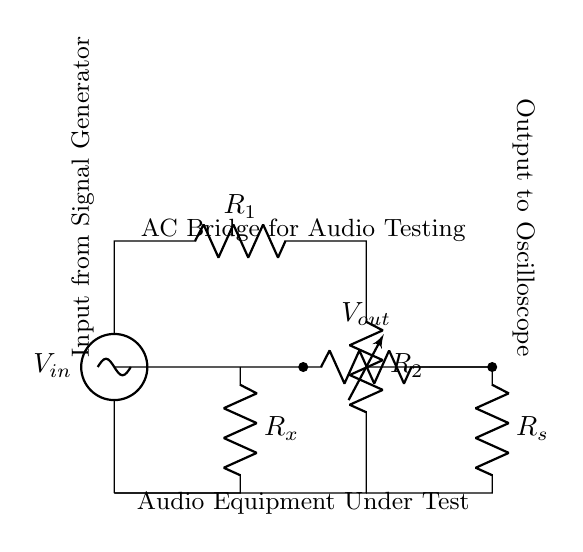What type of circuit is this? The circuit is an AC bridge, specifically designed for measuring and testing audio equipment by balancing different resistances.
Answer: AC bridge What does R_x represent in this circuit? R_x is the unknown resistance that is being measured or tested, often related to the characteristics of the audio equipment under evaluation.
Answer: Unknown resistance What is the purpose of the signal generator in this circuit? The signal generator provides an alternating current input (AC) voltage, which is necessary for the operation of the AC bridge and testing the audio equipment.
Answer: Provide AC input What is the role of R_s in the circuit? R_s acts as a standard resistance that is used for comparison purposes in the bridge circuit to help determine the value of R_x by achieving balance.
Answer: Standard resistance How is the output voltage related to the balance condition in this bridge circuit? The output voltage (V_out) will equal zero when the bridge is balanced, meaning that the ratios of resistances are equal, indicating that R_x and R_s are in proper equivalence for the measurement.
Answer: Indicates balance What would happen if R_2 is adjusted to match R_x? Adjusting R_2 to match R_x will help in achieving a balance condition in the circuit, leading to a zero output voltage, confirming the exact value of R_x through the bridge.
Answer: Achieves balance 